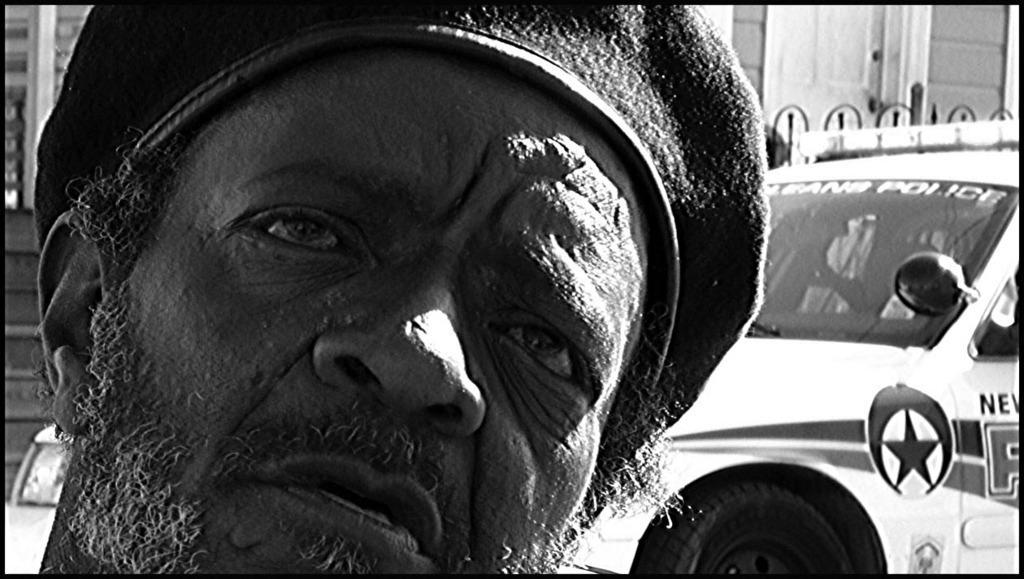Can you describe this image briefly? This picture is in black and white. Towards the left, there is a man with a hat. Towards the right, there is a vehicle. 